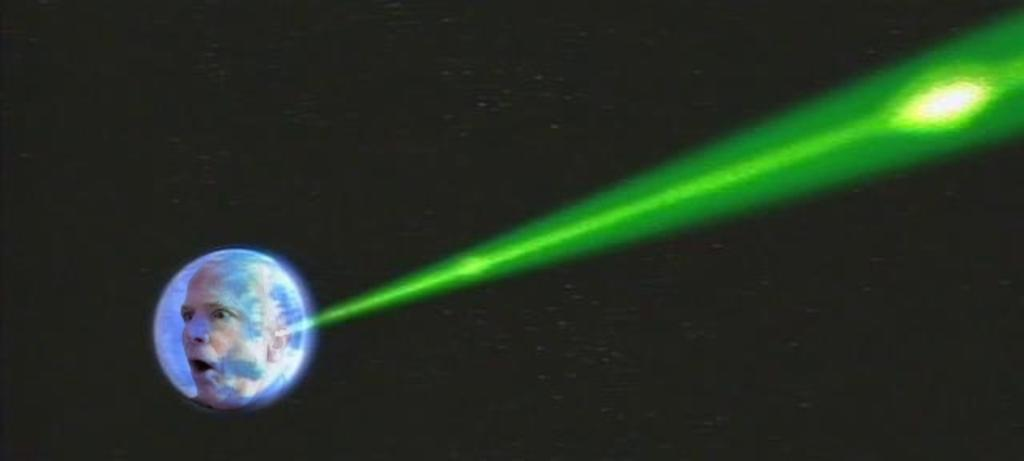What has been done to the image? The image has been edited. Can you describe the person in the image? There is a person in the image. Where is the person located in the image? The person is inside an object. What can be seen in the image that indicates the presence of light? There is light visible in the image. What is visible behind the person and object in the image? There is a background in the image. What songs can be heard playing in the background of the image? There is no audio or songs present in the image, as it is a still photograph. 